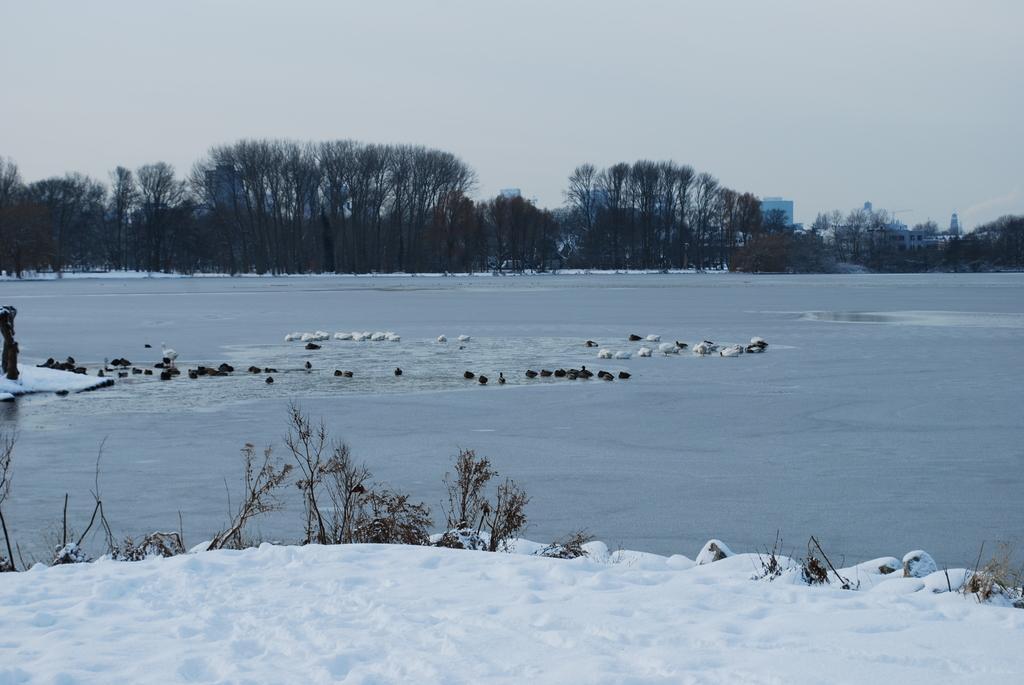In one or two sentences, can you explain what this image depicts? In this picture we can see plants, snow, water and birds. In the background we can see trees, buildings and the sky. 